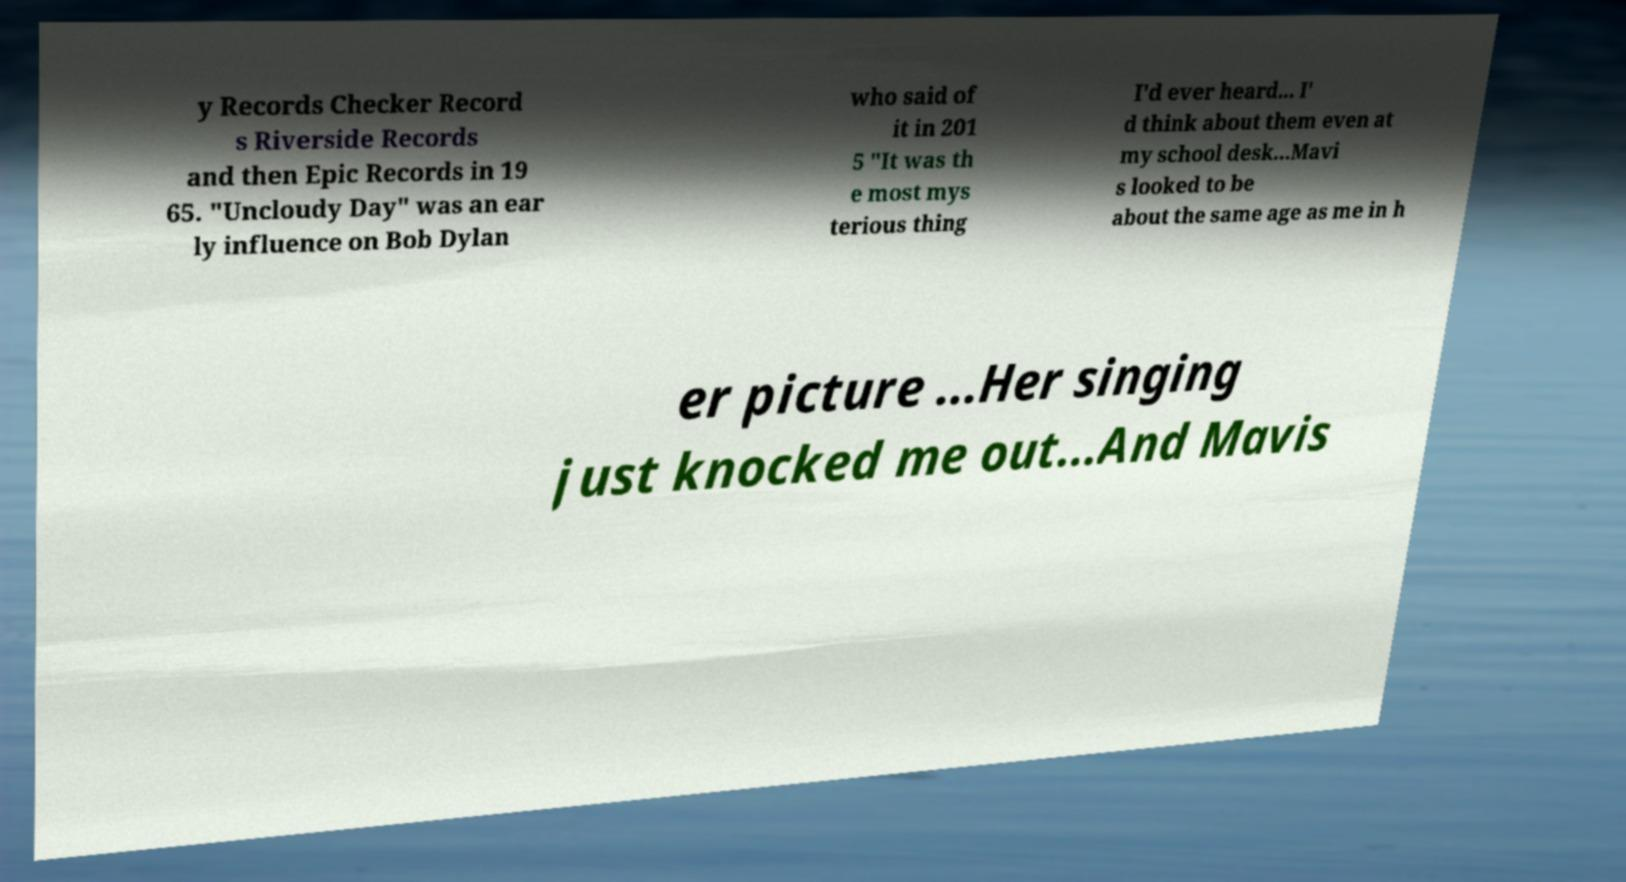What messages or text are displayed in this image? I need them in a readable, typed format. y Records Checker Record s Riverside Records and then Epic Records in 19 65. "Uncloudy Day" was an ear ly influence on Bob Dylan who said of it in 201 5 "It was th e most mys terious thing I'd ever heard... I' d think about them even at my school desk...Mavi s looked to be about the same age as me in h er picture ...Her singing just knocked me out...And Mavis 